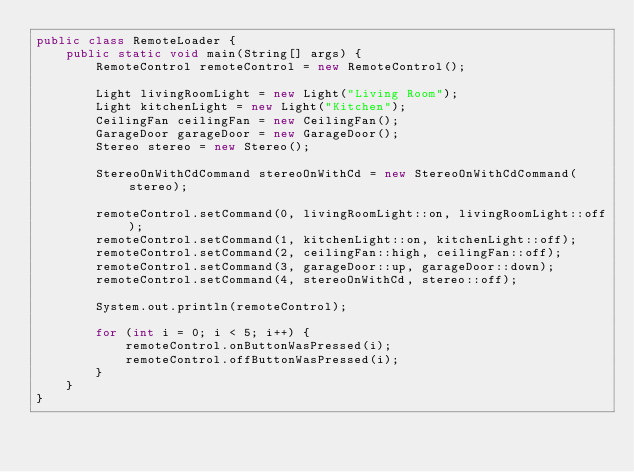Convert code to text. <code><loc_0><loc_0><loc_500><loc_500><_Java_>public class RemoteLoader {
    public static void main(String[] args) {
        RemoteControl remoteControl = new RemoteControl();

        Light livingRoomLight = new Light("Living Room");
        Light kitchenLight = new Light("Kitchen");
        CeilingFan ceilingFan = new CeilingFan();
        GarageDoor garageDoor = new GarageDoor();
        Stereo stereo = new Stereo();

        StereoOnWithCdCommand stereoOnWithCd = new StereoOnWithCdCommand(stereo);

        remoteControl.setCommand(0, livingRoomLight::on, livingRoomLight::off);
        remoteControl.setCommand(1, kitchenLight::on, kitchenLight::off);
        remoteControl.setCommand(2, ceilingFan::high, ceilingFan::off);
        remoteControl.setCommand(3, garageDoor::up, garageDoor::down);
        remoteControl.setCommand(4, stereoOnWithCd, stereo::off);

        System.out.println(remoteControl);

        for (int i = 0; i < 5; i++) {
            remoteControl.onButtonWasPressed(i);
            remoteControl.offButtonWasPressed(i);
        }
    }
}
</code> 